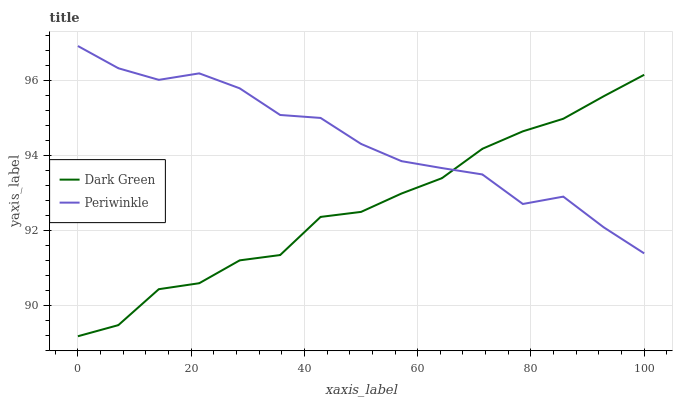Does Dark Green have the minimum area under the curve?
Answer yes or no. Yes. Does Periwinkle have the maximum area under the curve?
Answer yes or no. Yes. Does Dark Green have the maximum area under the curve?
Answer yes or no. No. Is Dark Green the smoothest?
Answer yes or no. Yes. Is Periwinkle the roughest?
Answer yes or no. Yes. Is Dark Green the roughest?
Answer yes or no. No. Does Dark Green have the lowest value?
Answer yes or no. Yes. Does Periwinkle have the highest value?
Answer yes or no. Yes. Does Dark Green have the highest value?
Answer yes or no. No. Does Periwinkle intersect Dark Green?
Answer yes or no. Yes. Is Periwinkle less than Dark Green?
Answer yes or no. No. Is Periwinkle greater than Dark Green?
Answer yes or no. No. 